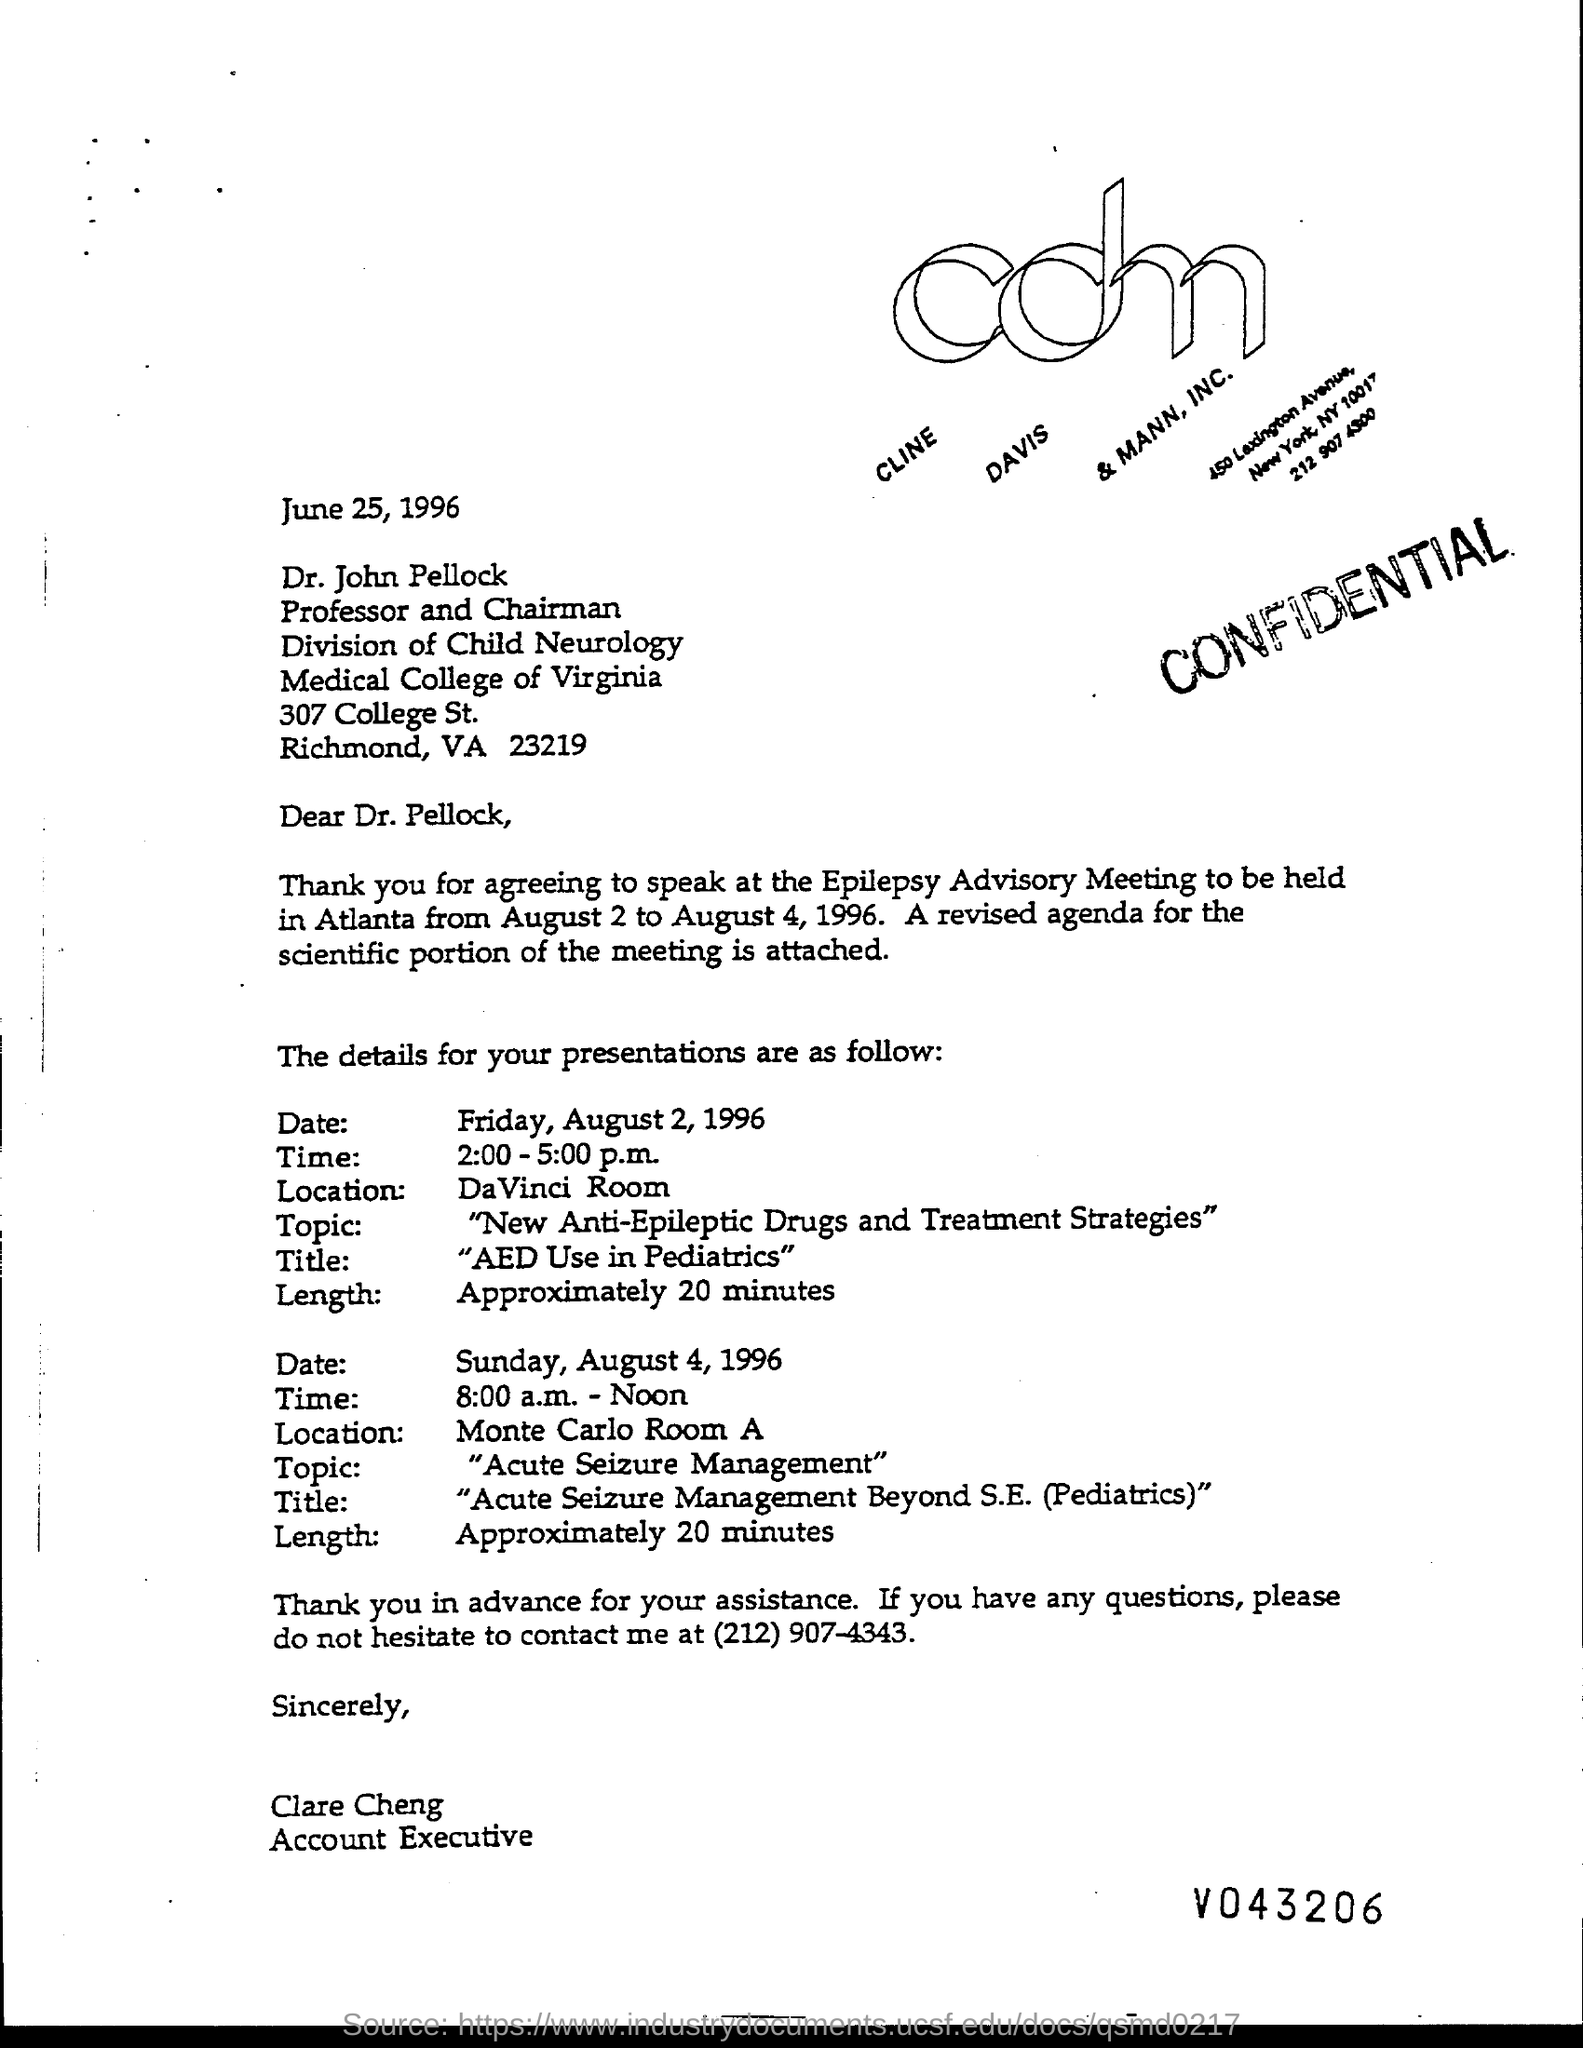What is the security level of the document?
Offer a very short reply. CONFIDENTIAL. To whom the letter is addressed?
Provide a short and direct response. Dr. John Pellock. What is the presentation time on Friday, August 2, 1996?
Keep it short and to the point. 2:00-5:00 p.m. What is the presentation time on Sunday, August 4, 1996?
Ensure brevity in your answer.  8:00 a.m. - Noon. Who wrote the letter?
Your answer should be compact. Clare Cheng. What is the title of the presentation on Friday, August 2, 1996?
Provide a succinct answer. "AED USE IN PEDIATRICS". What is the title of the presentation on Sunday, August 4, 1996?
Provide a short and direct response. "ACUTE SEIZURE MANAGEMENT BEYOND S.E.(PEDIATRICS)". 